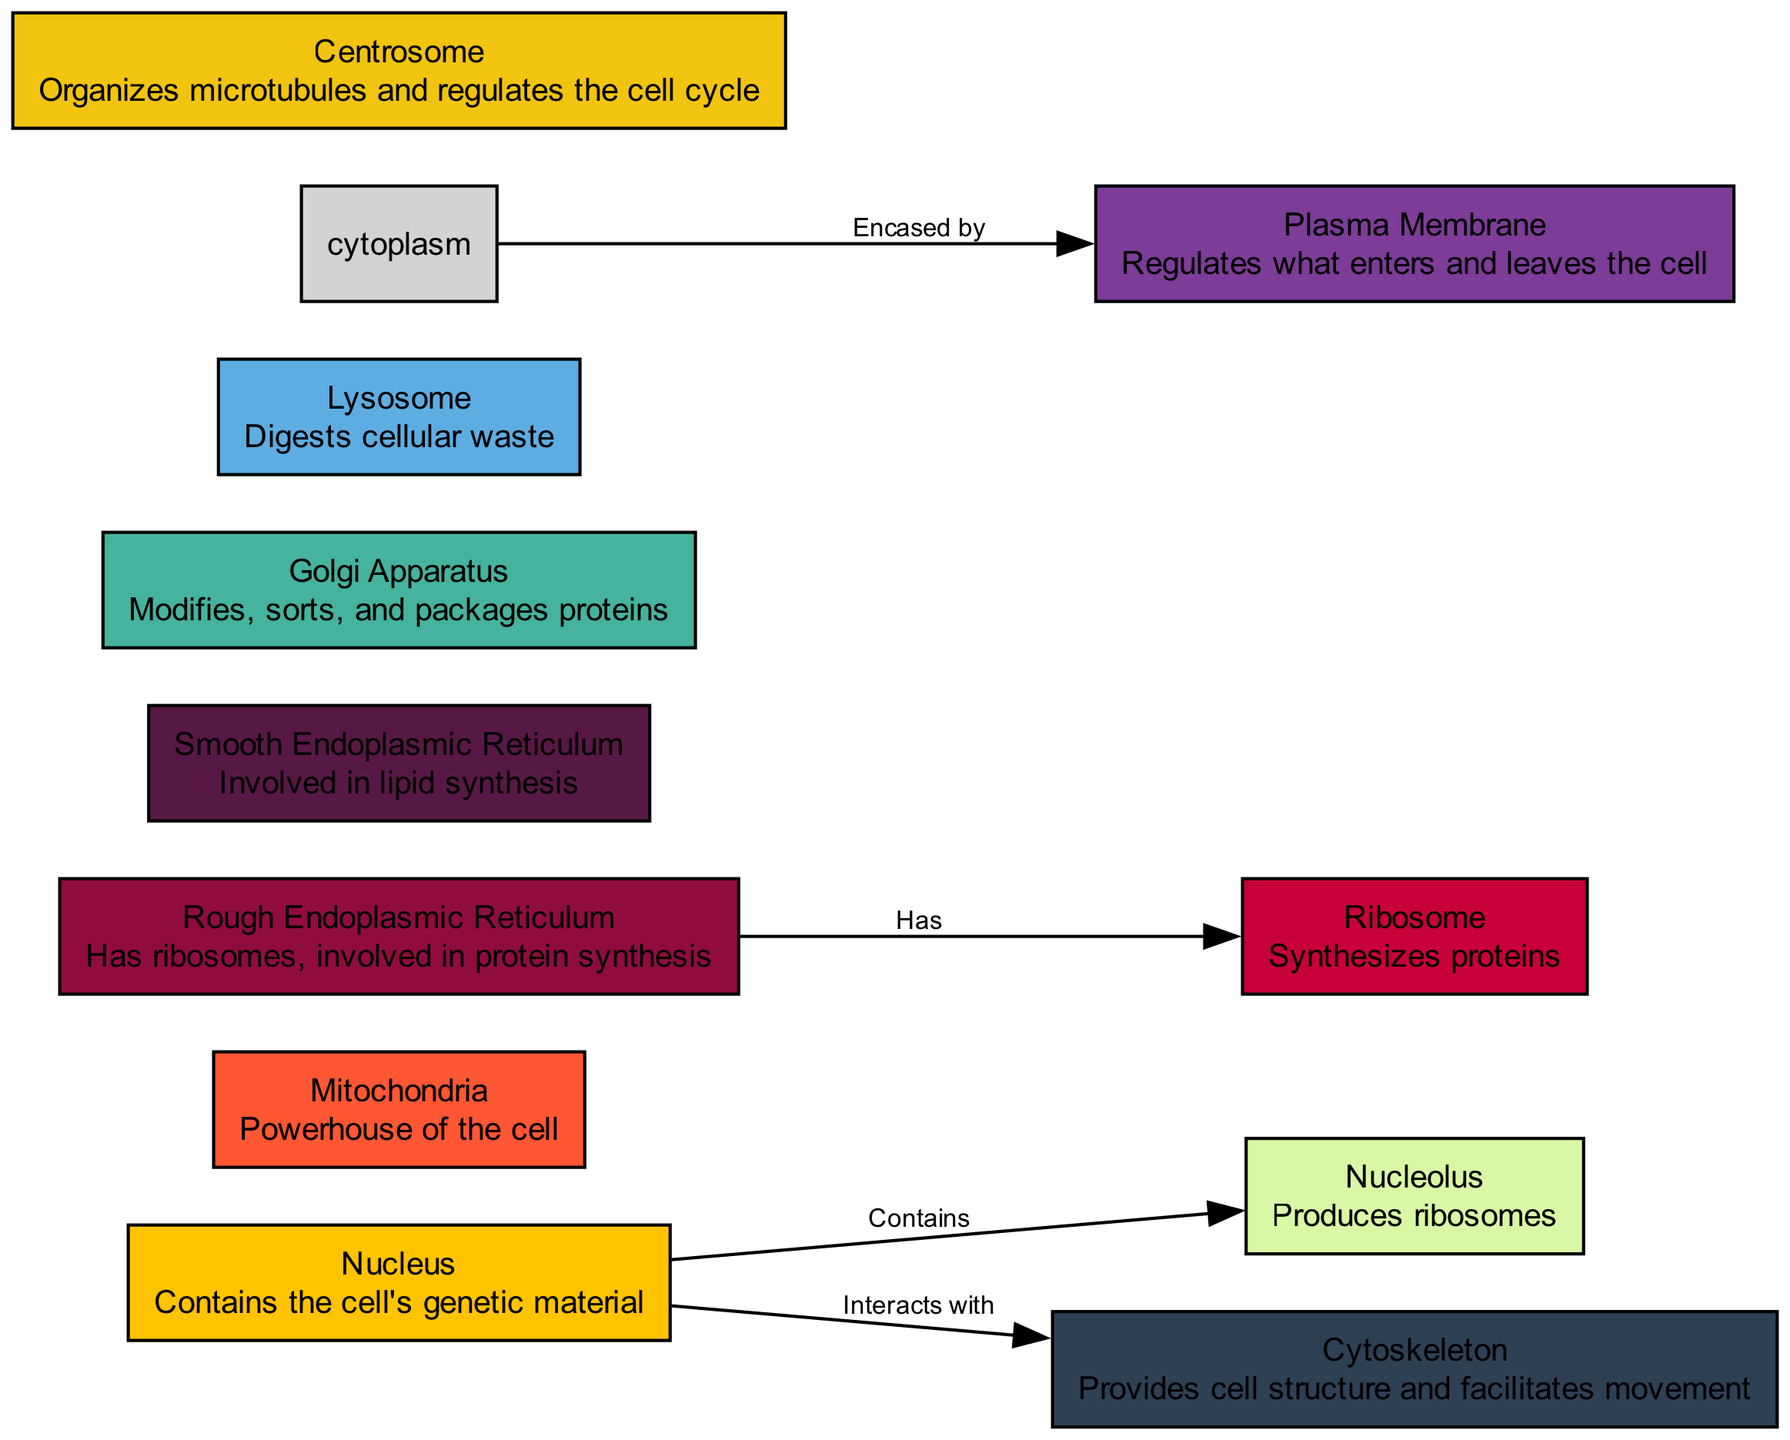What is the function of the Golgi Apparatus? The Golgi Apparatus modifies, sorts, and packages proteins, as indicated in the diagram's description for that organelle.
Answer: Modifies, sorts, and packages proteins How many organelles are shown in the diagram? Counting the nodes in the diagram, there are a total of 11 organelles displayed.
Answer: 11 Which organelle is described as the "Powerhouse of the cell"? The description for Mitochondria explicitly identifies it as the "Powerhouse of the cell."
Answer: Mitochondria What does the Rough Endoplasmic Reticulum have? The edge connecting the Rough Endoplasmic Reticulum to Ribosome states that it "Has" ribosomes, confirming this relationship.
Answer: Ribosomes What does the Cytoskeleton provide for the cell? According to the description in the diagram, the Cytoskeleton provides cell structure and facilitates movement.
Answer: Cell structure and facilitates movement Which two organelles interact with the Nucleus according to the diagram? The Nucleus interacts with the Cytoskeleton, and it also contains the Nucleolus, making these two organelles relevant in this context.
Answer: Cytoskeleton and Nucleolus What role does the Lysosome play in the cell? The description states that the Lysosome digests cellular waste, which is its primary function in the context of the diagram.
Answer: Digests cellular waste What regulates what enters and leaves the cell? The Plasma Membrane is identified in the diagram as regulating what enters and leaves the cell.
Answer: Plasma Membrane Which organelle is responsible for synthesizing proteins? The Ribosome is highlighted in the diagram as the organelle that synthesizes proteins.
Answer: Ribosome What organizes microtubules and regulates the cell cycle? The diagram specifies that the Centrosome organizes microtubules and regulates the cell cycle.
Answer: Centrosome 